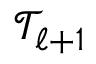<formula> <loc_0><loc_0><loc_500><loc_500>\mathcal { T } _ { \ell + 1 }</formula> 